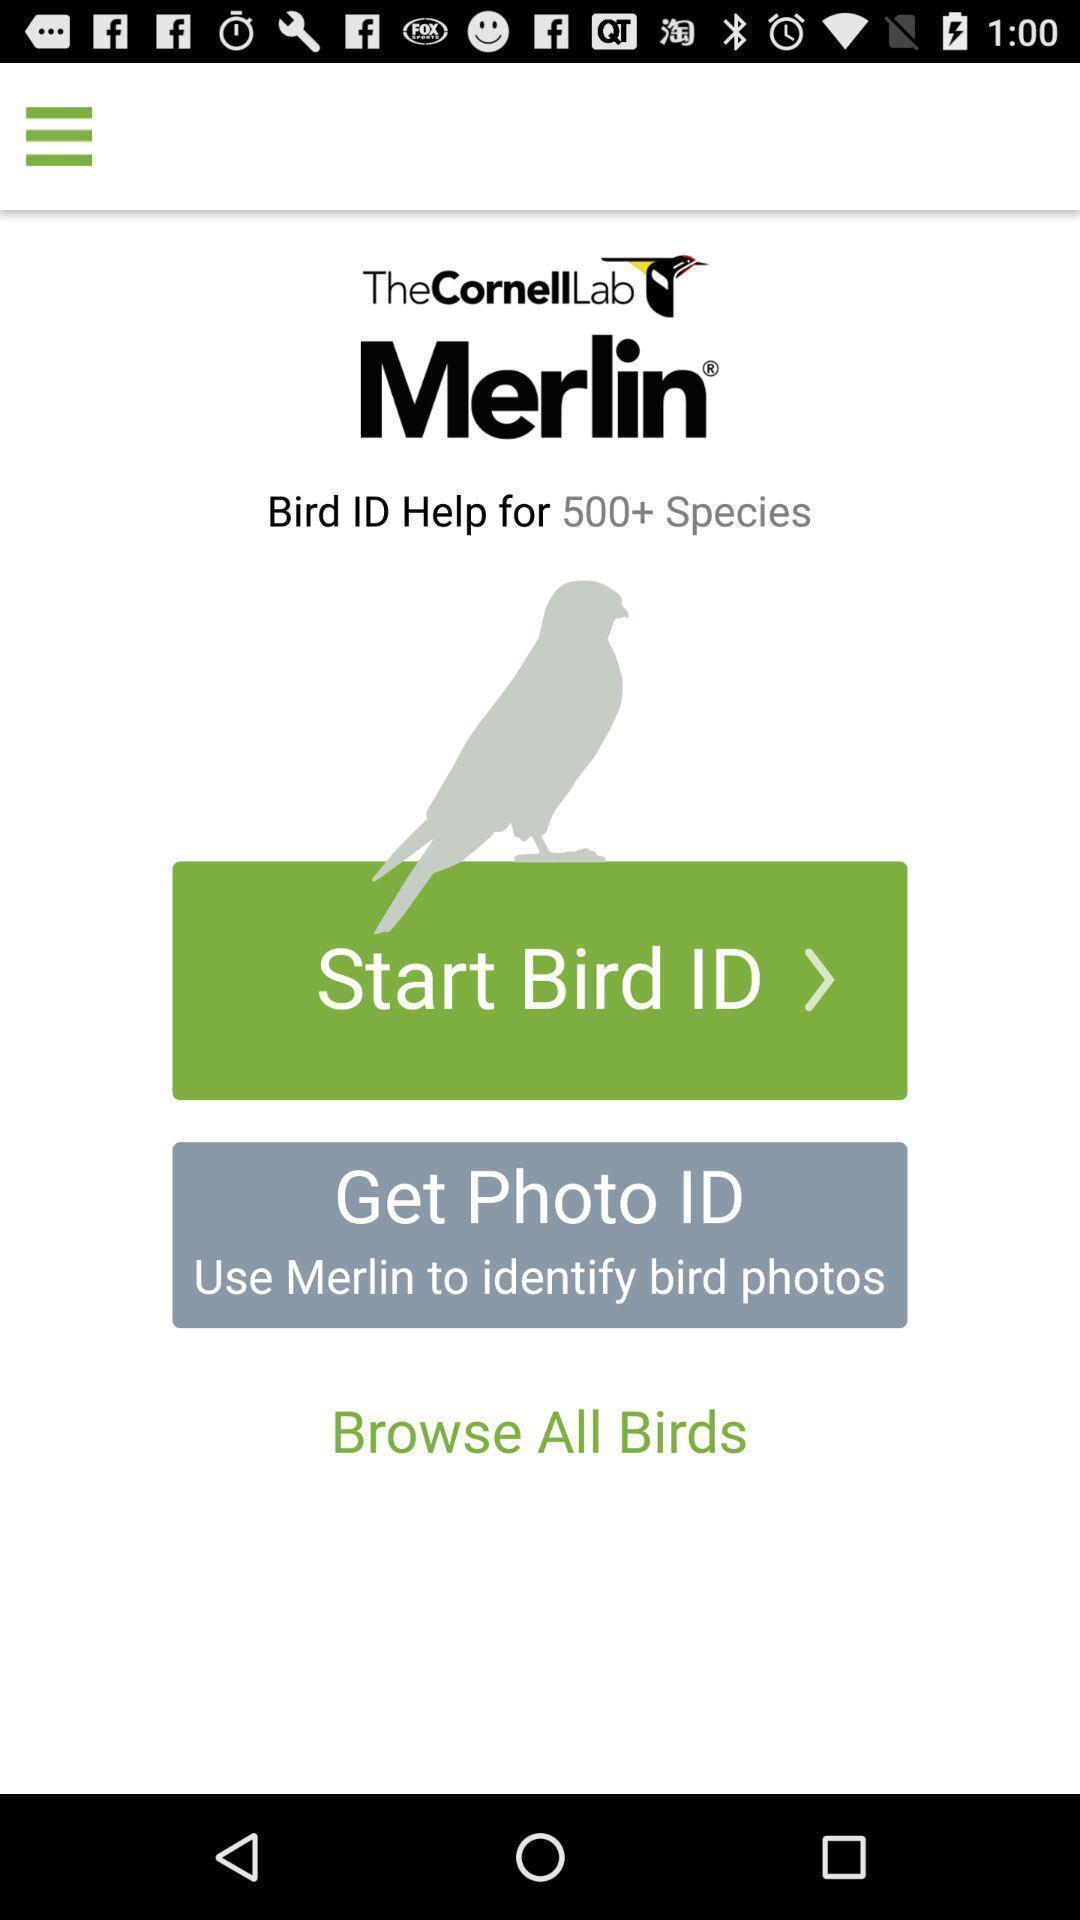Explain what's happening in this screen capture. Welcome page. 